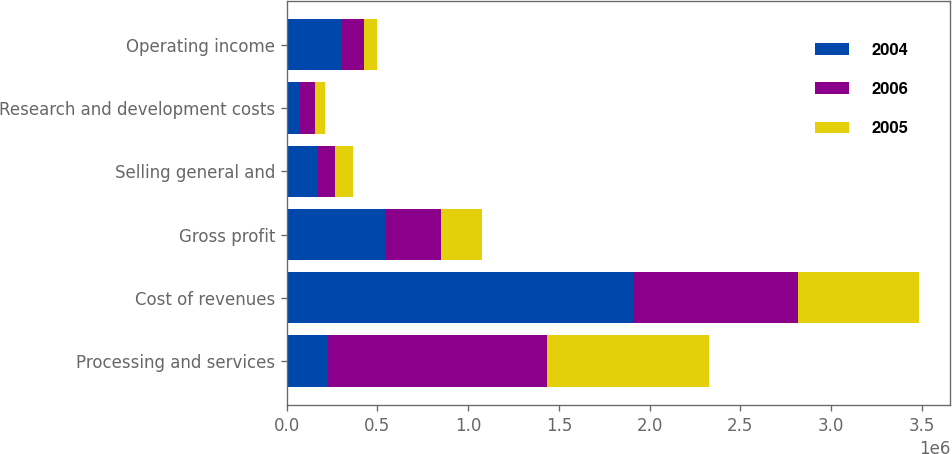<chart> <loc_0><loc_0><loc_500><loc_500><stacked_bar_chart><ecel><fcel>Processing and services<fcel>Cost of revenues<fcel>Gross profit<fcel>Selling general and<fcel>Research and development costs<fcel>Operating income<nl><fcel>2004<fcel>224955<fcel>1.91415e+06<fcel>544629<fcel>171106<fcel>70879<fcel>302644<nl><fcel>2006<fcel>1.20843e+06<fcel>904124<fcel>304306<fcel>94889<fcel>85702<fcel>123715<nl><fcel>2005<fcel>892033<fcel>667078<fcel>224955<fcel>99581<fcel>54038<fcel>71336<nl></chart> 